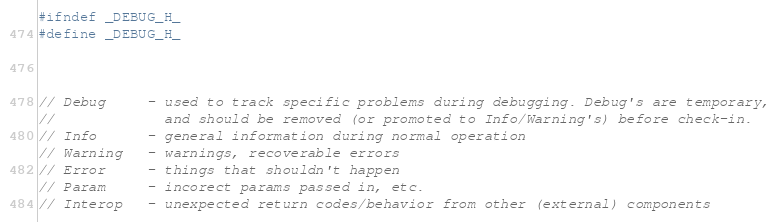<code> <loc_0><loc_0><loc_500><loc_500><_C_>
#ifndef _DEBUG_H_
#define _DEBUG_H_



// Debug     - used to track specific problems during debugging. Debug's are temporary,
//             and should be removed (or promoted to Info/Warning's) before check-in.
// Info      - general information during normal operation
// Warning   - warnings, recoverable errors
// Error     - things that shouldn't happen
// Param     - incorect params passed in, etc.
// Interop   - unexpected return codes/behavior from other (external) components</code> 